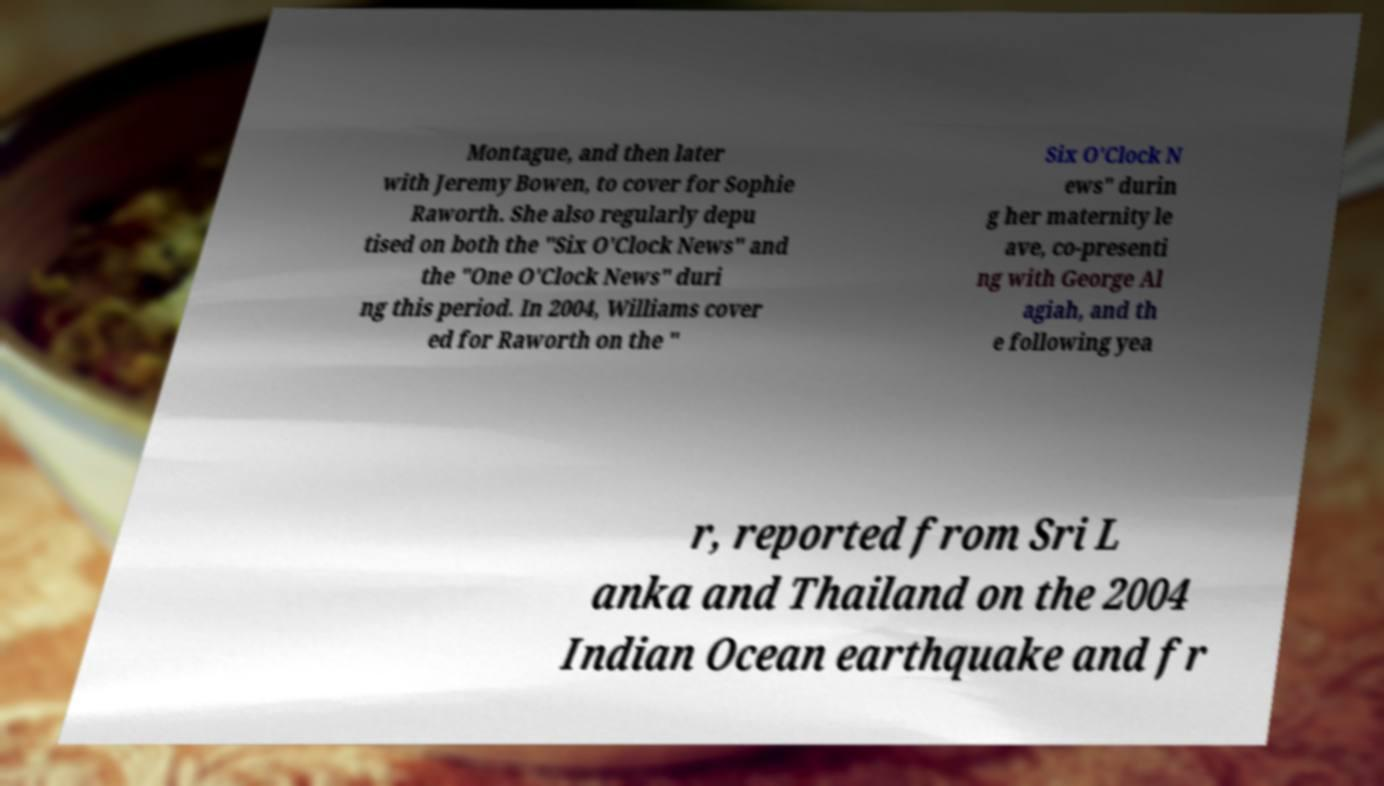Could you assist in decoding the text presented in this image and type it out clearly? Montague, and then later with Jeremy Bowen, to cover for Sophie Raworth. She also regularly depu tised on both the "Six O'Clock News" and the "One O'Clock News" duri ng this period. In 2004, Williams cover ed for Raworth on the " Six O'Clock N ews" durin g her maternity le ave, co-presenti ng with George Al agiah, and th e following yea r, reported from Sri L anka and Thailand on the 2004 Indian Ocean earthquake and fr 